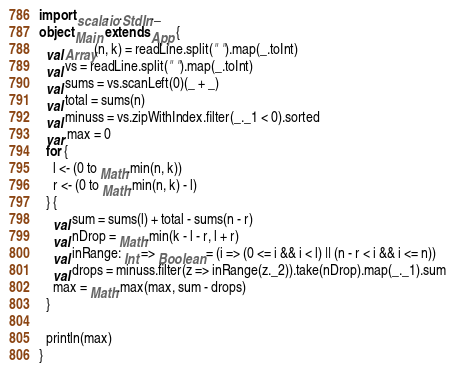Convert code to text. <code><loc_0><loc_0><loc_500><loc_500><_Scala_>import scala.io.StdIn._
object Main extends App {
  val Array(n, k) = readLine.split(" ").map(_.toInt)
  val vs = readLine.split(" ").map(_.toInt)
  val sums = vs.scanLeft(0)(_ + _)
  val total = sums(n)
  val minuss = vs.zipWithIndex.filter(_._1 < 0).sorted
  var max = 0
  for {
    l <- (0 to Math.min(n, k))
    r <- (0 to Math.min(n, k) - l)
  } {
    val sum = sums(l) + total - sums(n - r)
    val nDrop = Math.min(k - l - r, l + r)
    val inRange: Int => Boolean = (i => (0 <= i && i < l) || (n - r < i && i <= n))
    val drops = minuss.filter(z => inRange(z._2)).take(nDrop).map(_._1).sum
    max = Math.max(max, sum - drops)
  }

  println(max)
}</code> 